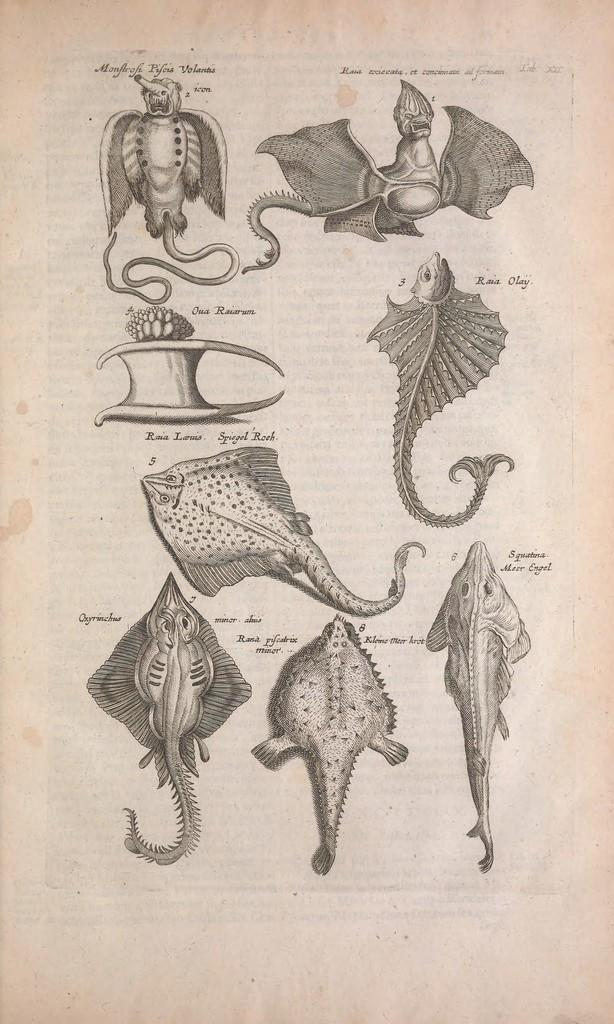What is depicted on the paper in the image? There are diagrams and written text on a paper in the image. Can you describe the diagrams on the paper? Unfortunately, the specific details of the diagrams cannot be determined from the image alone. What is the purpose of the written text on the paper? The purpose of the written text on the paper cannot be determined from the image alone. Where is the actor sitting on the throne in the image? There is no actor or throne present in the image. What additional details can be seen on the diagrams in the image? The specific details of the diagrams cannot be determined from the image alone. 